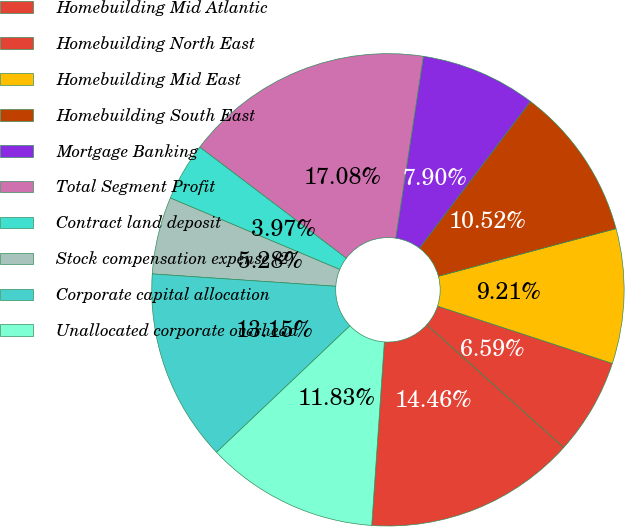Convert chart to OTSL. <chart><loc_0><loc_0><loc_500><loc_500><pie_chart><fcel>Homebuilding Mid Atlantic<fcel>Homebuilding North East<fcel>Homebuilding Mid East<fcel>Homebuilding South East<fcel>Mortgage Banking<fcel>Total Segment Profit<fcel>Contract land deposit<fcel>Stock compensation expense (2)<fcel>Corporate capital allocation<fcel>Unallocated corporate overhead<nl><fcel>14.45%<fcel>6.59%<fcel>9.21%<fcel>10.52%<fcel>7.9%<fcel>17.07%<fcel>3.97%<fcel>5.28%<fcel>13.14%<fcel>11.83%<nl></chart> 